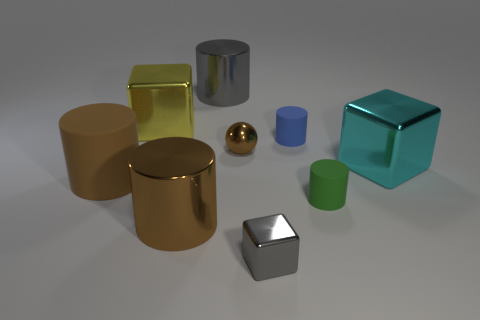There is a shiny object that is to the right of the cube in front of the large shiny block that is on the right side of the large gray metallic cylinder; what color is it?
Keep it short and to the point. Cyan. Are there any large cyan objects that have the same shape as the green matte object?
Make the answer very short. No. There is a cylinder that is the same size as the green rubber thing; what is its color?
Make the answer very short. Blue. There is a small cylinder that is right of the blue matte thing; what is its material?
Keep it short and to the point. Rubber. Is the shape of the large brown object that is behind the brown metallic cylinder the same as the gray thing in front of the yellow block?
Your answer should be very brief. No. Are there the same number of small blue rubber objects left of the big brown matte cylinder and big gray balls?
Keep it short and to the point. Yes. How many brown things are made of the same material as the yellow object?
Keep it short and to the point. 2. What is the color of the small sphere that is made of the same material as the tiny gray thing?
Keep it short and to the point. Brown. There is a green thing; is its size the same as the metal cylinder that is behind the green thing?
Provide a succinct answer. No. There is a brown rubber object; what shape is it?
Your answer should be compact. Cylinder. 